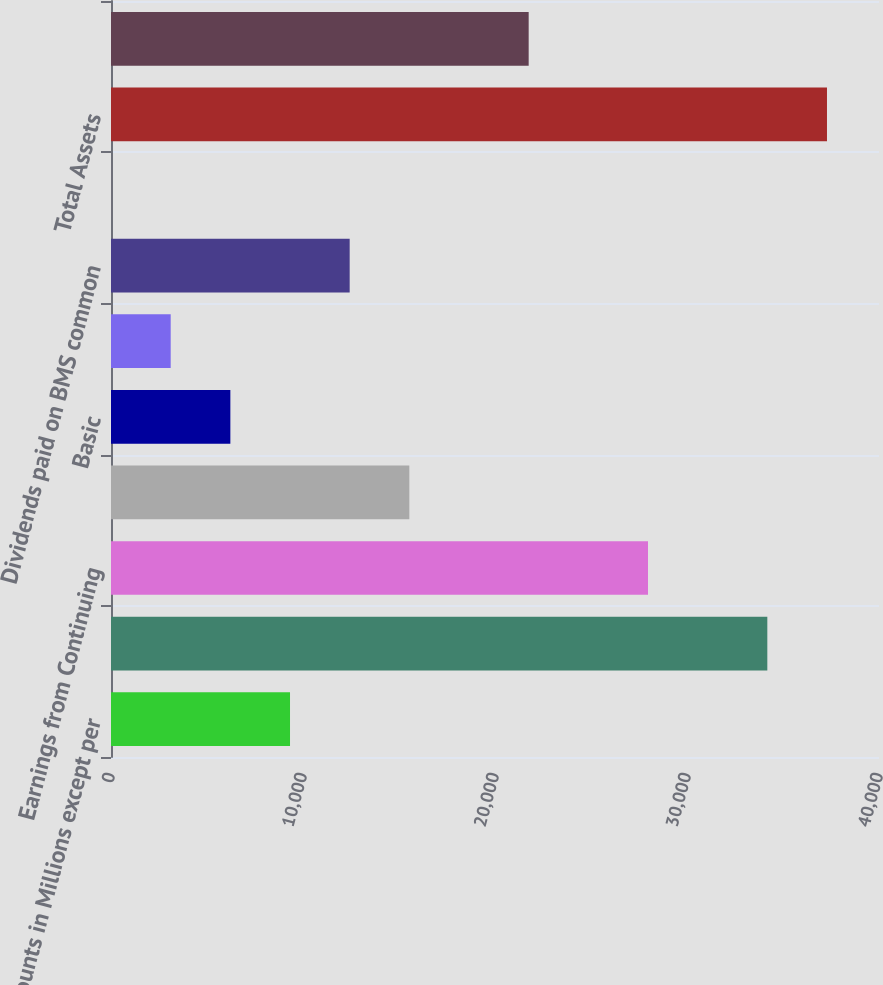Convert chart. <chart><loc_0><loc_0><loc_500><loc_500><bar_chart><fcel>Amounts in Millions except per<fcel>Net Sales<fcel>Earnings from Continuing<fcel>Net Earnings from Continuing<fcel>Basic<fcel>Diluted<fcel>Dividends paid on BMS common<fcel>Dividends declared per common<fcel>Total Assets<fcel>Cash and cash equivalents<nl><fcel>9323.7<fcel>34183.5<fcel>27968.5<fcel>15538.6<fcel>6216.23<fcel>3108.76<fcel>12431.2<fcel>1.29<fcel>37290.9<fcel>21753.6<nl></chart> 